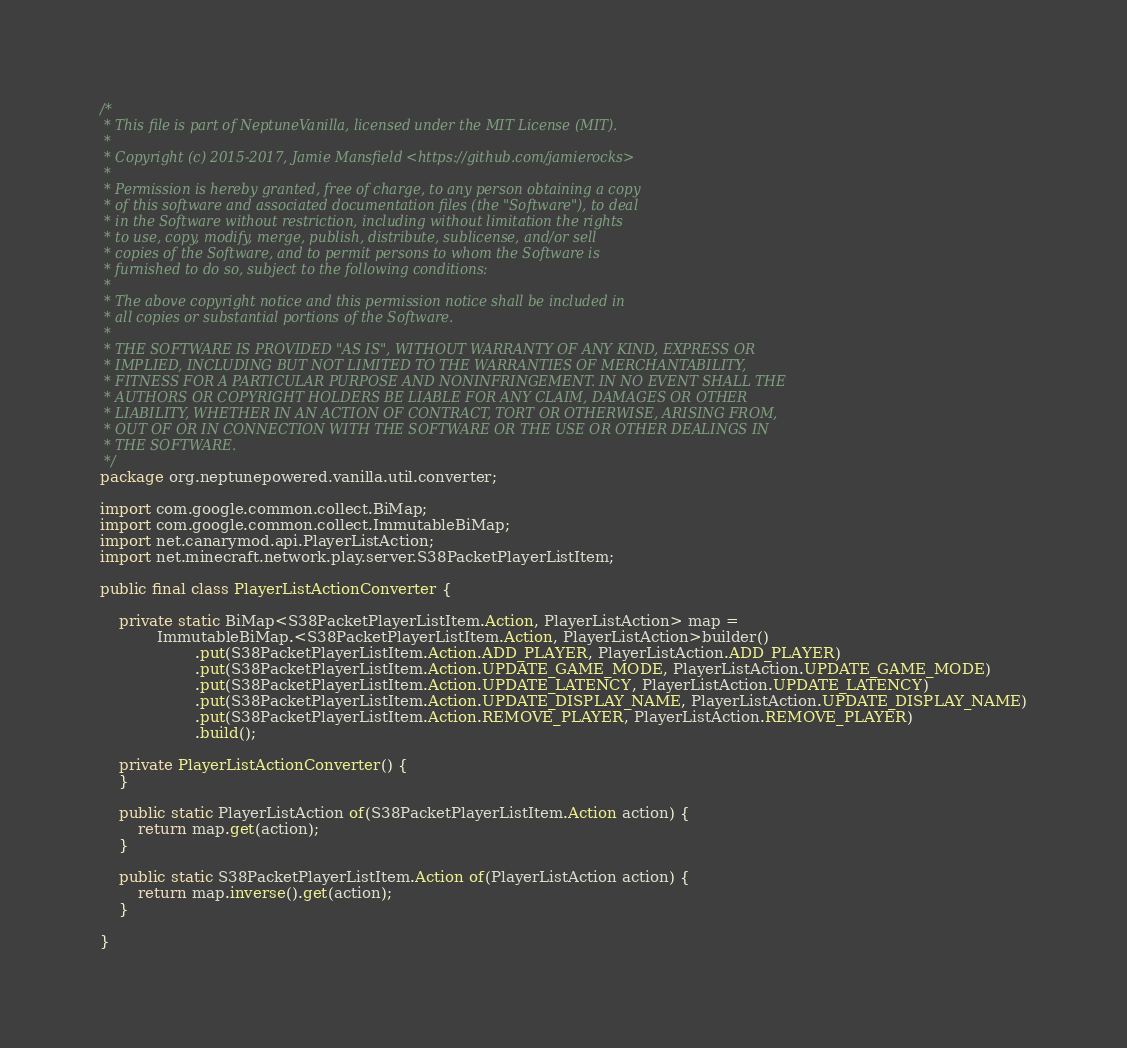Convert code to text. <code><loc_0><loc_0><loc_500><loc_500><_Java_>/*
 * This file is part of NeptuneVanilla, licensed under the MIT License (MIT).
 *
 * Copyright (c) 2015-2017, Jamie Mansfield <https://github.com/jamierocks>
 *
 * Permission is hereby granted, free of charge, to any person obtaining a copy
 * of this software and associated documentation files (the "Software"), to deal
 * in the Software without restriction, including without limitation the rights
 * to use, copy, modify, merge, publish, distribute, sublicense, and/or sell
 * copies of the Software, and to permit persons to whom the Software is
 * furnished to do so, subject to the following conditions:
 *
 * The above copyright notice and this permission notice shall be included in
 * all copies or substantial portions of the Software.
 *
 * THE SOFTWARE IS PROVIDED "AS IS", WITHOUT WARRANTY OF ANY KIND, EXPRESS OR
 * IMPLIED, INCLUDING BUT NOT LIMITED TO THE WARRANTIES OF MERCHANTABILITY,
 * FITNESS FOR A PARTICULAR PURPOSE AND NONINFRINGEMENT. IN NO EVENT SHALL THE
 * AUTHORS OR COPYRIGHT HOLDERS BE LIABLE FOR ANY CLAIM, DAMAGES OR OTHER
 * LIABILITY, WHETHER IN AN ACTION OF CONTRACT, TORT OR OTHERWISE, ARISING FROM,
 * OUT OF OR IN CONNECTION WITH THE SOFTWARE OR THE USE OR OTHER DEALINGS IN
 * THE SOFTWARE.
 */
package org.neptunepowered.vanilla.util.converter;

import com.google.common.collect.BiMap;
import com.google.common.collect.ImmutableBiMap;
import net.canarymod.api.PlayerListAction;
import net.minecraft.network.play.server.S38PacketPlayerListItem;

public final class PlayerListActionConverter {

    private static BiMap<S38PacketPlayerListItem.Action, PlayerListAction> map =
            ImmutableBiMap.<S38PacketPlayerListItem.Action, PlayerListAction>builder()
                    .put(S38PacketPlayerListItem.Action.ADD_PLAYER, PlayerListAction.ADD_PLAYER)
                    .put(S38PacketPlayerListItem.Action.UPDATE_GAME_MODE, PlayerListAction.UPDATE_GAME_MODE)
                    .put(S38PacketPlayerListItem.Action.UPDATE_LATENCY, PlayerListAction.UPDATE_LATENCY)
                    .put(S38PacketPlayerListItem.Action.UPDATE_DISPLAY_NAME, PlayerListAction.UPDATE_DISPLAY_NAME)
                    .put(S38PacketPlayerListItem.Action.REMOVE_PLAYER, PlayerListAction.REMOVE_PLAYER)
                    .build();

    private PlayerListActionConverter() {
    }

    public static PlayerListAction of(S38PacketPlayerListItem.Action action) {
        return map.get(action);
    }

    public static S38PacketPlayerListItem.Action of(PlayerListAction action) {
        return map.inverse().get(action);
    }

}
</code> 